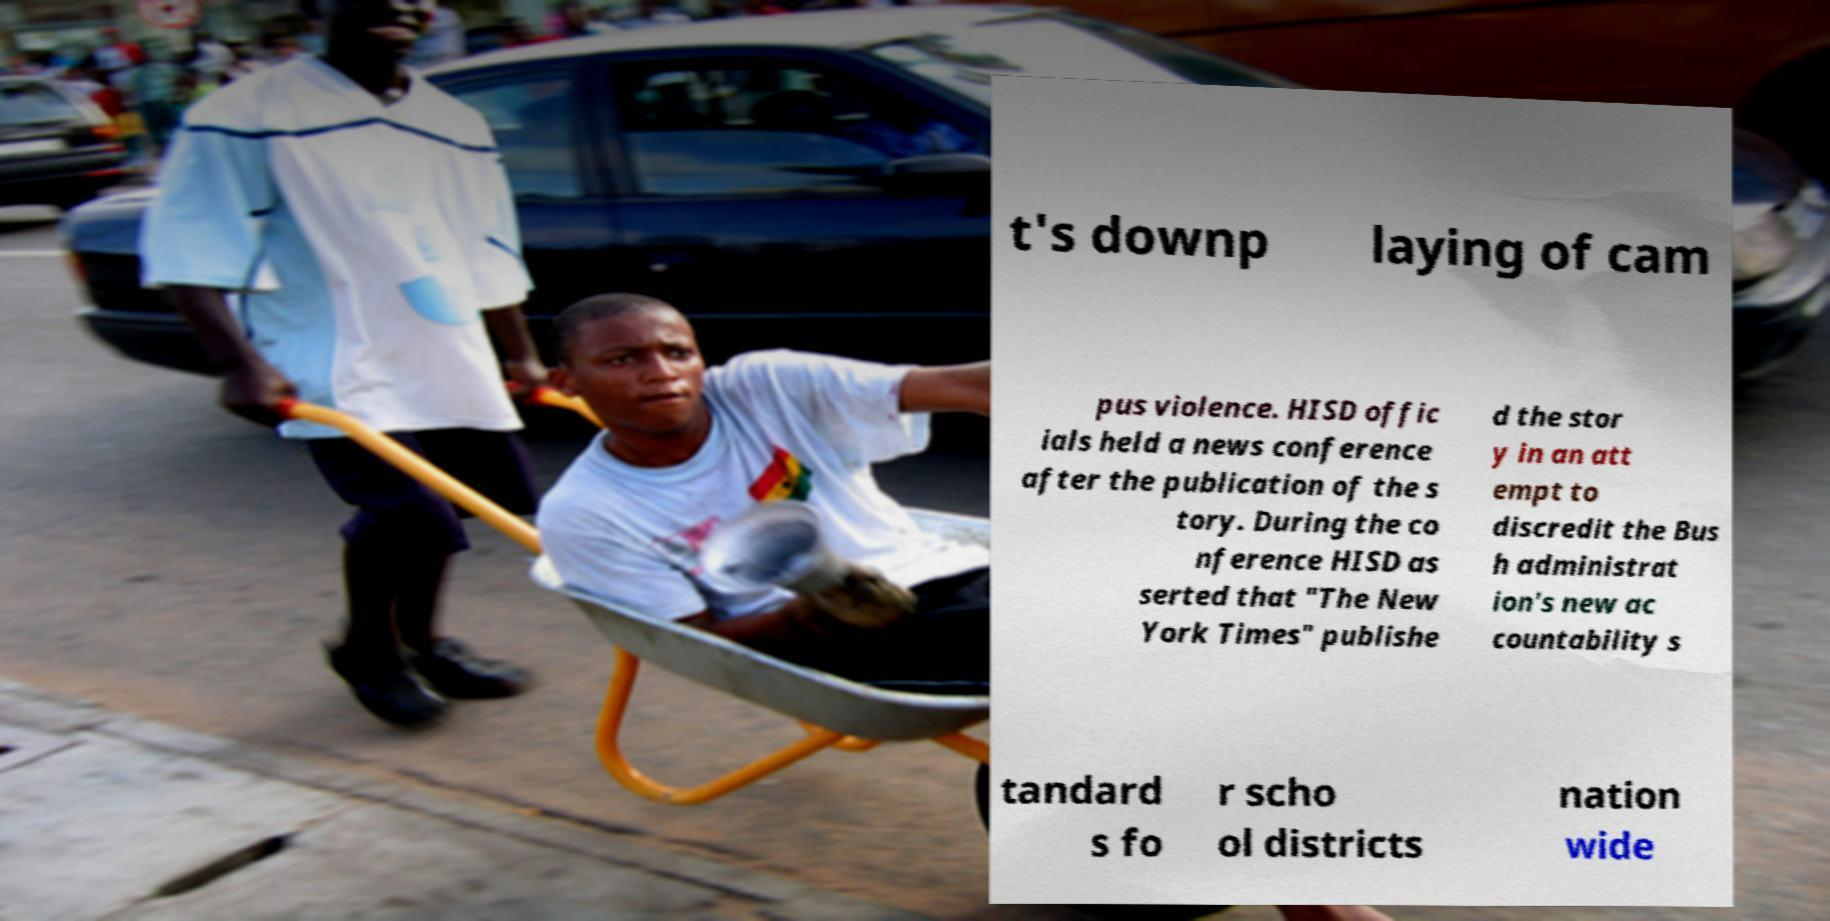Can you read and provide the text displayed in the image?This photo seems to have some interesting text. Can you extract and type it out for me? t's downp laying of cam pus violence. HISD offic ials held a news conference after the publication of the s tory. During the co nference HISD as serted that "The New York Times" publishe d the stor y in an att empt to discredit the Bus h administrat ion's new ac countability s tandard s fo r scho ol districts nation wide 